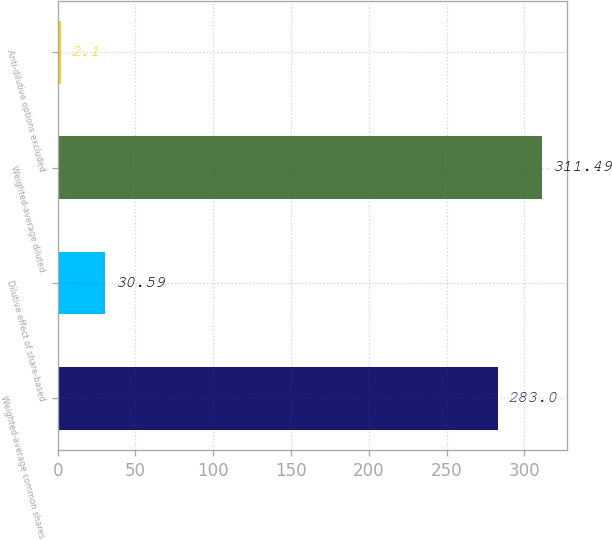Convert chart. <chart><loc_0><loc_0><loc_500><loc_500><bar_chart><fcel>Weighted-average common shares<fcel>Dilutive effect of share-based<fcel>Weighted-average diluted<fcel>Anti-dilutive options excluded<nl><fcel>283<fcel>30.59<fcel>311.49<fcel>2.1<nl></chart> 